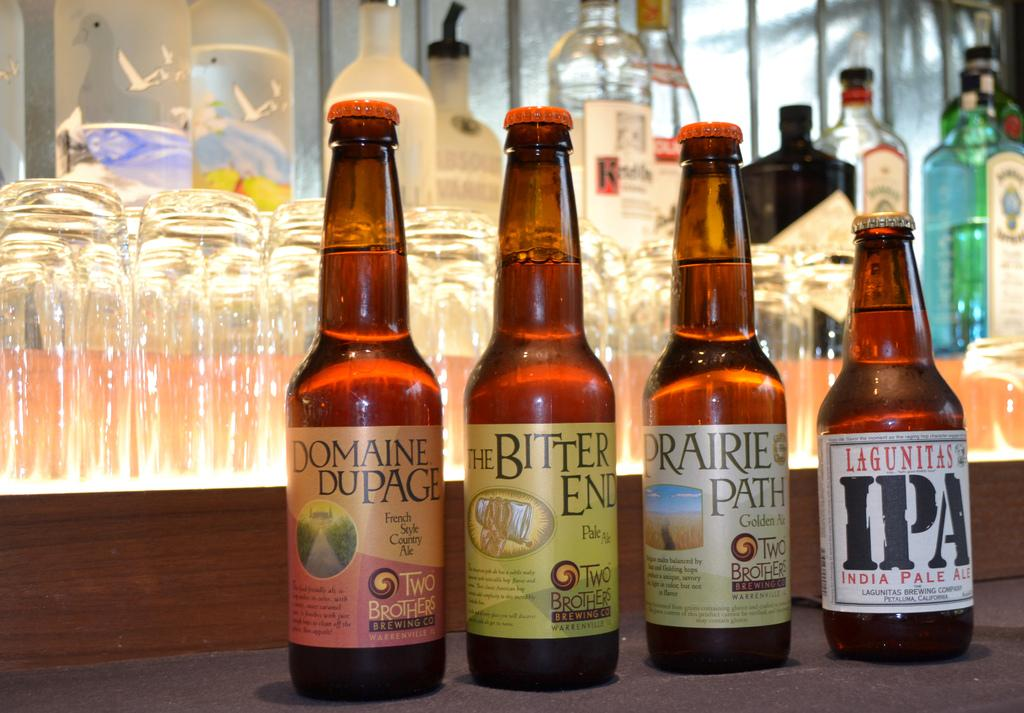Provide a one-sentence caption for the provided image. Four bottles of two brothers beer each of a different flavour sit on a counter. 